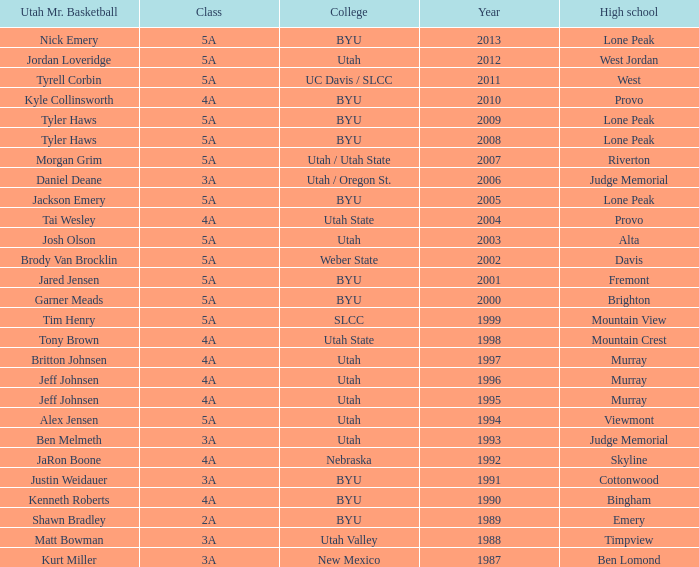Where did Tyler Haws, 2009 Utah Mr. Basketball, go to high school? Lone Peak. 